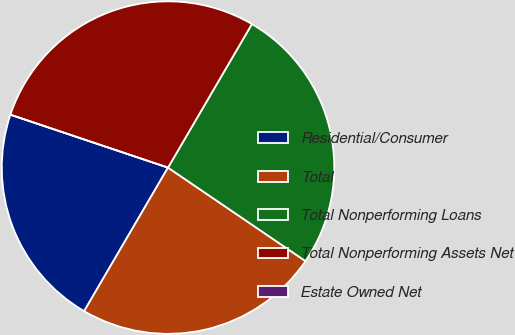Convert chart. <chart><loc_0><loc_0><loc_500><loc_500><pie_chart><fcel>Residential/Consumer<fcel>Total<fcel>Total Nonperforming Loans<fcel>Total Nonperforming Assets Net<fcel>Estate Owned Net<nl><fcel>21.74%<fcel>23.91%<fcel>26.09%<fcel>28.26%<fcel>0.0%<nl></chart> 